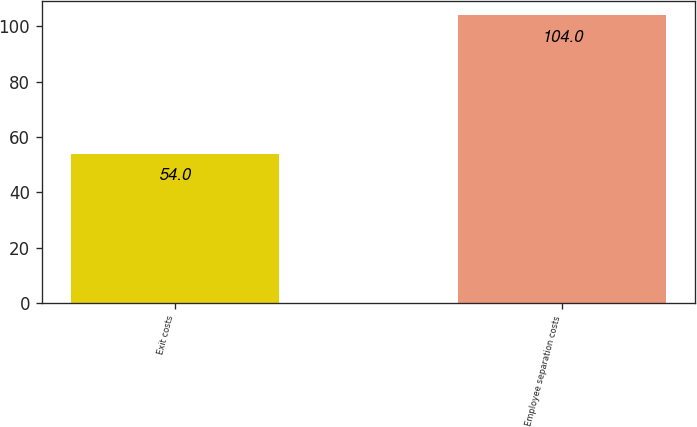Convert chart to OTSL. <chart><loc_0><loc_0><loc_500><loc_500><bar_chart><fcel>Exit costs<fcel>Employee separation costs<nl><fcel>54<fcel>104<nl></chart> 